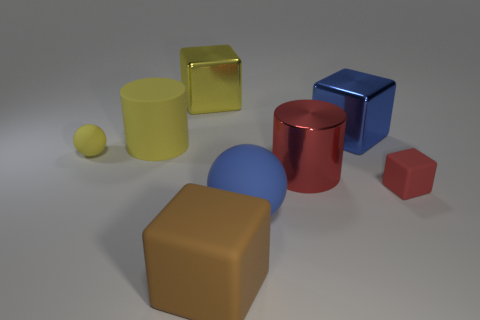The metal cylinder that is the same color as the tiny cube is what size?
Offer a terse response. Large. What is the size of the block that is both in front of the big yellow rubber thing and on the left side of the small block?
Offer a terse response. Large. There is a rubber sphere to the right of the rubber ball left of the large yellow thing on the left side of the large yellow metallic block; how big is it?
Your answer should be compact. Large. The yellow matte ball has what size?
Offer a very short reply. Small. Is there a rubber thing that is on the left side of the big blue object in front of the large cylinder on the right side of the large brown object?
Offer a terse response. Yes. How many tiny objects are either red cylinders or gray matte blocks?
Keep it short and to the point. 0. Is there any other thing of the same color as the large matte block?
Keep it short and to the point. No. Does the metallic cube to the left of the brown block have the same size as the small matte ball?
Your answer should be compact. No. What is the color of the large cylinder in front of the cylinder that is left of the cube in front of the tiny block?
Offer a terse response. Red. What color is the rubber cylinder?
Give a very brief answer. Yellow. 